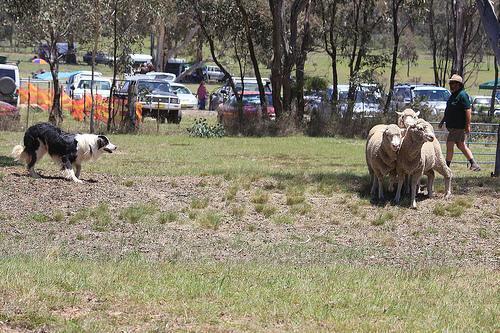How many black sheeps are there?
Give a very brief answer. 0. 